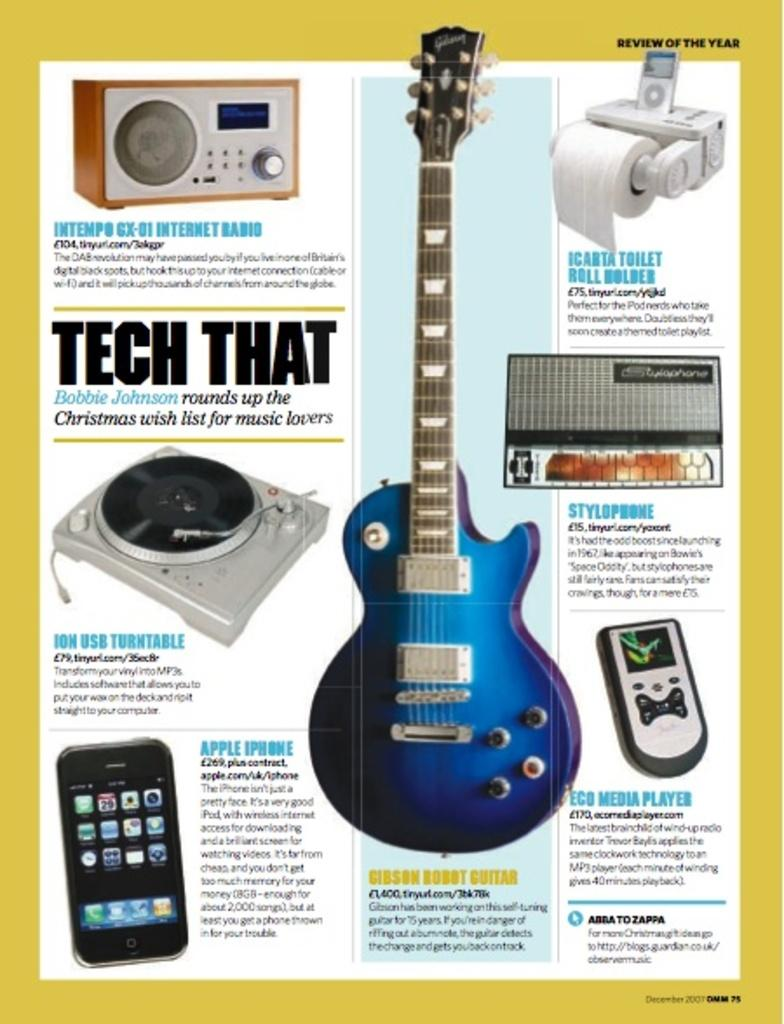<image>
Summarize the visual content of the image. A Tech That article has several products showing including an Eco Media Player and a Gibson Robot Guitar. 